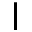Convert formula to latex. <formula><loc_0><loc_0><loc_500><loc_500>I</formula> 